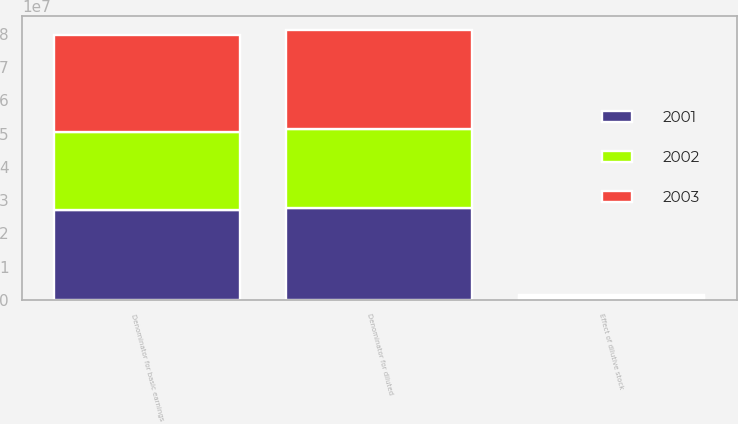<chart> <loc_0><loc_0><loc_500><loc_500><stacked_bar_chart><ecel><fcel>Denominator for basic earnings<fcel>Effect of dilutive stock<fcel>Denominator for diluted<nl><fcel>2003<fcel>2.90313e+07<fcel>679564<fcel>2.97109e+07<nl><fcel>2001<fcel>2.70021e+07<fcel>646964<fcel>2.76491e+07<nl><fcel>2002<fcel>2.36481e+07<fcel>266646<fcel>2.39148e+07<nl></chart> 